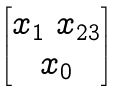Convert formula to latex. <formula><loc_0><loc_0><loc_500><loc_500>\begin{bmatrix} x _ { 1 } \ x _ { 2 3 } \\ x _ { 0 } \end{bmatrix}</formula> 